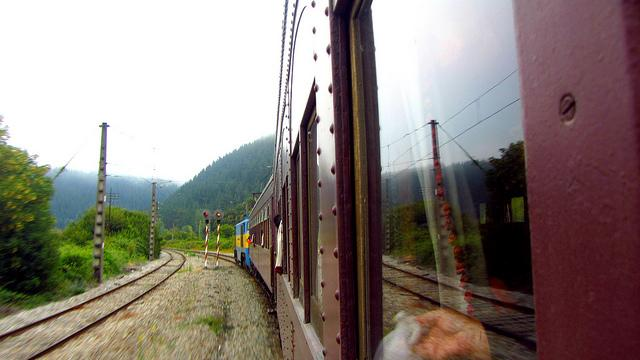Why is the train stopped? Please explain your reasoning. red light. In the front of the train there is a traffic signal on the left of it.  since the signal has a red light on, this would explain the train being stopped. 